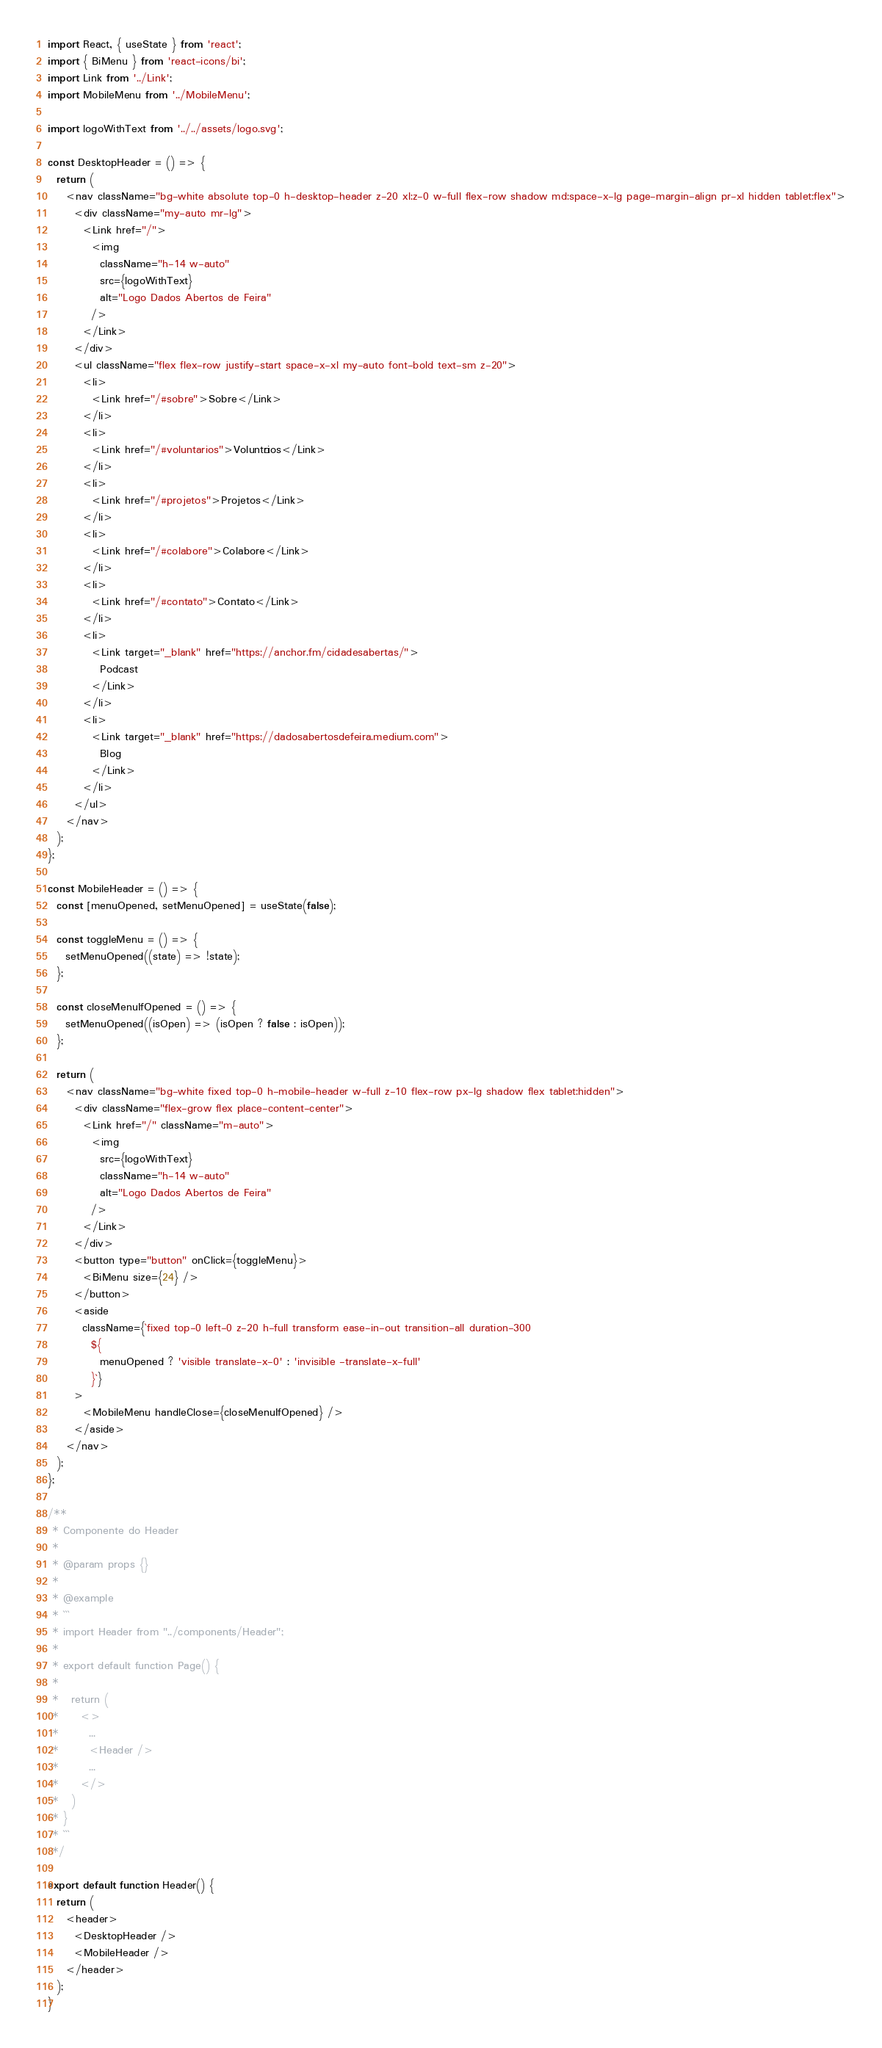<code> <loc_0><loc_0><loc_500><loc_500><_JavaScript_>import React, { useState } from 'react';
import { BiMenu } from 'react-icons/bi';
import Link from '../Link';
import MobileMenu from '../MobileMenu';

import logoWithText from '../../assets/logo.svg';

const DesktopHeader = () => {
  return (
    <nav className="bg-white absolute top-0 h-desktop-header z-20 xl:z-0 w-full flex-row shadow md:space-x-lg page-margin-align pr-xl hidden tablet:flex">
      <div className="my-auto mr-lg">
        <Link href="/">
          <img
            className="h-14 w-auto"
            src={logoWithText}
            alt="Logo Dados Abertos de Feira"
          />
        </Link>
      </div>
      <ul className="flex flex-row justify-start space-x-xl my-auto font-bold text-sm z-20">
        <li>
          <Link href="/#sobre">Sobre</Link>
        </li>
        <li>
          <Link href="/#voluntarios">Voluntários</Link>
        </li>
        <li>
          <Link href="/#projetos">Projetos</Link>
        </li>
        <li>
          <Link href="/#colabore">Colabore</Link>
        </li>
        <li>
          <Link href="/#contato">Contato</Link>
        </li>
        <li>
          <Link target="_blank" href="https://anchor.fm/cidadesabertas/">
            Podcast
          </Link>
        </li>
        <li>
          <Link target="_blank" href="https://dadosabertosdefeira.medium.com">
            Blog
          </Link>
        </li>
      </ul>
    </nav>
  );
};

const MobileHeader = () => {
  const [menuOpened, setMenuOpened] = useState(false);

  const toggleMenu = () => {
    setMenuOpened((state) => !state);
  };

  const closeMenuIfOpened = () => {
    setMenuOpened((isOpen) => (isOpen ? false : isOpen));
  };

  return (
    <nav className="bg-white fixed top-0 h-mobile-header w-full z-10 flex-row px-lg shadow flex tablet:hidden">
      <div className="flex-grow flex place-content-center">
        <Link href="/" className="m-auto">
          <img
            src={logoWithText}
            className="h-14 w-auto"
            alt="Logo Dados Abertos de Feira"
          />
        </Link>
      </div>
      <button type="button" onClick={toggleMenu}>
        <BiMenu size={24} />
      </button>
      <aside
        className={`fixed top-0 left-0 z-20 h-full transform ease-in-out transition-all duration-300
          ${
            menuOpened ? 'visible translate-x-0' : 'invisible -translate-x-full'
          }`}
      >
        <MobileMenu handleClose={closeMenuIfOpened} />
      </aside>
    </nav>
  );
};

/**
 * Componente do Header
 *
 * @param props {}
 *
 * @example
 * ```
 * import Header from "../components/Header";
 *
 * export default function Page() {
 *
 *   return (
 *     <>
 *       ...
 *       <Header />
 *       ...
 *     </>
 *   )
 * }
 * ```
 */

export default function Header() {
  return (
    <header>
      <DesktopHeader />
      <MobileHeader />
    </header>
  );
}
</code> 